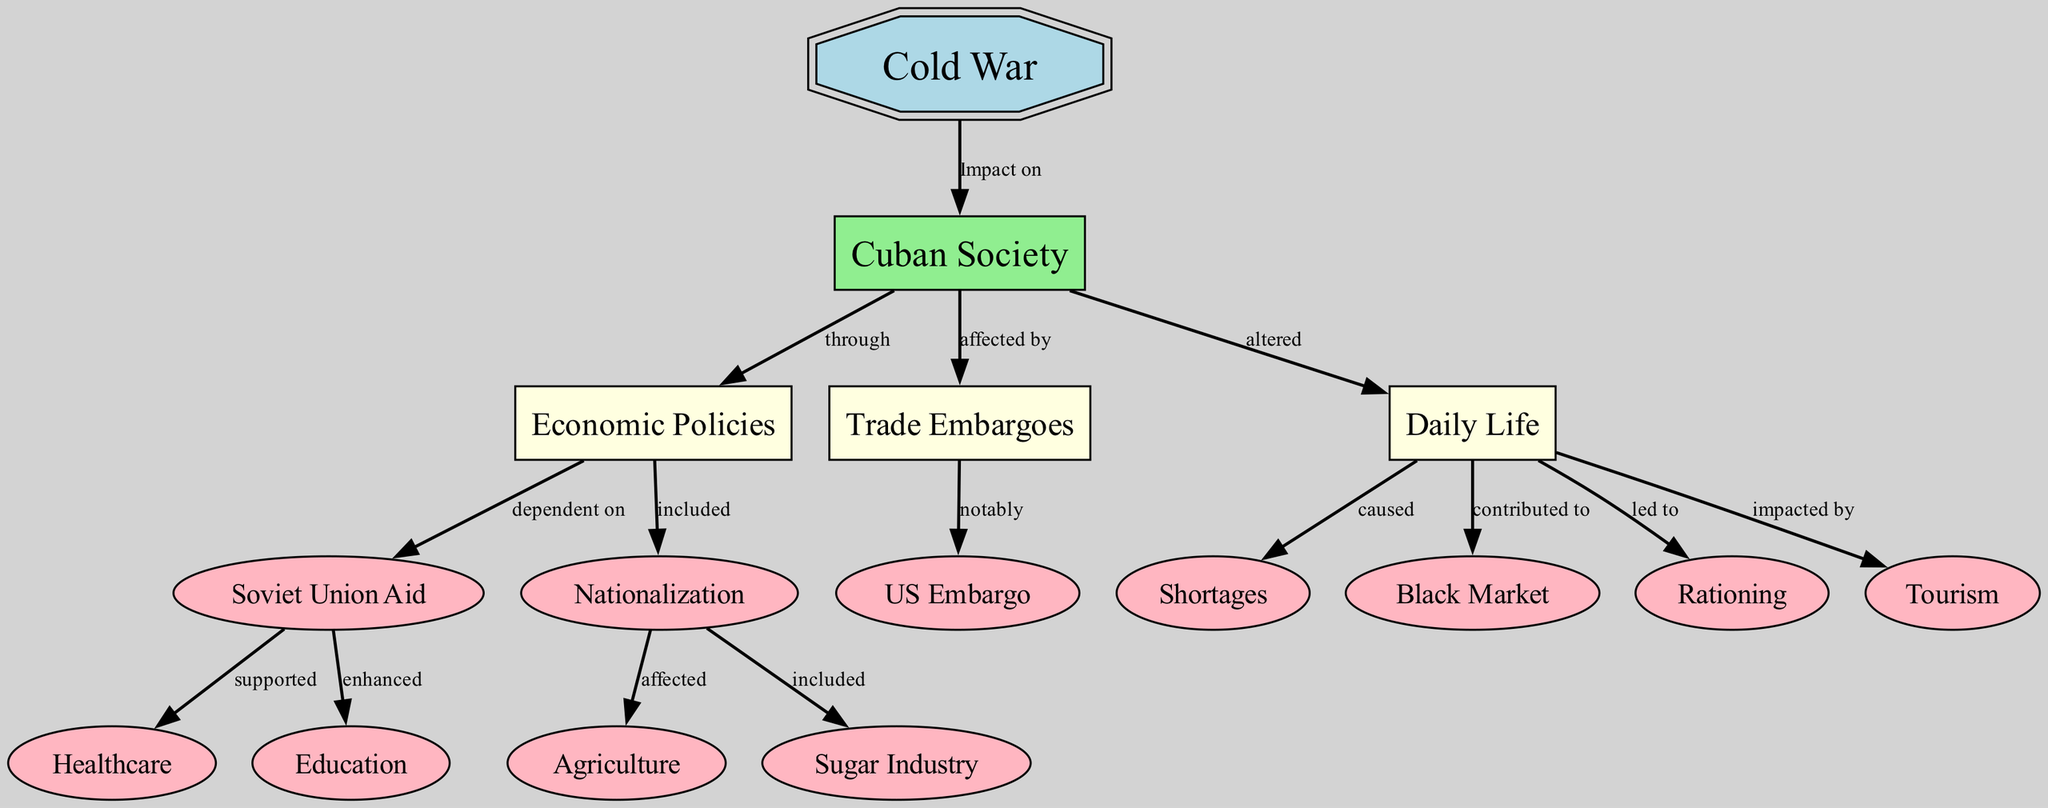What is the main focus of the concept map? The concept map centers around the socioeconomic impacts of the Cold War on Cuban society, illustrating various fallouts and influences stemming from this historical period.
Answer: Socioeconomic impacts of the Cold War How many nodes are present in the diagram? By counting each unique node representing a key concept, we find that there are a total of 15 nodes in the diagram.
Answer: 15 What economic policy is included under Cuban Society? The policy of nationalization is a key economic strategy included as a response to the Cold War's influence on Cuban society.
Answer: Nationalization Which country’s aid is emphasized in the economic policies? The diagram indicates that the aid received from the Soviet Union is a significant aspect of economic policies during the Cold War in Cuba.
Answer: Soviet Union What is primarily caused by daily life alterations in Cuban society? The diagram shows that shortages in daily life arise due to the alterations resulting from the Cold War's impact on Cuban society.
Answer: Shortages What led to the development of a black market in Cuba? The contribution of various factors within daily life and the resultant economic conditions led to the fosterage of a black market during the Cold War period.
Answer: Daily Life How is the US embargo described in relation to trade embargoes? The US embargo is notably highlighted as a pivotal element affecting trade embargoes during the Cold War's influence on Cuban society.
Answer: Notably What two sectors of society were supported by Soviet Union aid? Soviet Union aid notably supported the healthcare and education sectors, enhancing their development despite Cold War challenges.
Answer: Healthcare and Education How does nationalization affect agriculture? Nationalization is shown to directly affect the agricultural sector, significantly altering its structure in response to Cold War influences.
Answer: Affected 